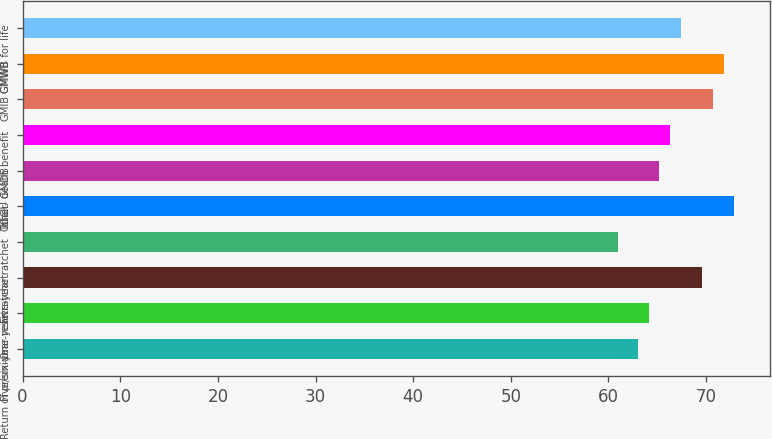Convert chart. <chart><loc_0><loc_0><loc_500><loc_500><bar_chart><fcel>Return of premium<fcel>Five/six-year reset<fcel>One-year ratchet<fcel>Five-year ratchet<fcel>Other<fcel>Total - GMDB<fcel>GGU death benefit<fcel>GMIB<fcel>GMWB<fcel>GMWB for life<nl><fcel>63<fcel>64.1<fcel>69.6<fcel>61<fcel>72.9<fcel>65.2<fcel>66.3<fcel>70.7<fcel>71.8<fcel>67.4<nl></chart> 